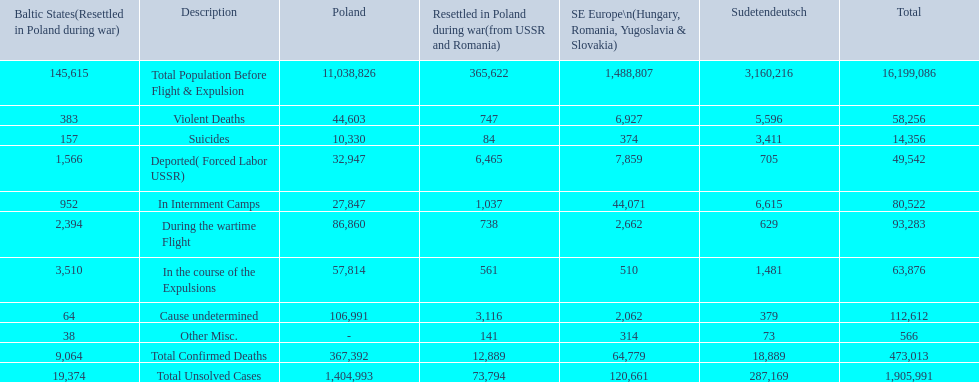What are the numbers of violent deaths across the area? 44,603, 383, 747, 5,596, 6,927. What is the total number of violent deaths of the area? 58,256. 